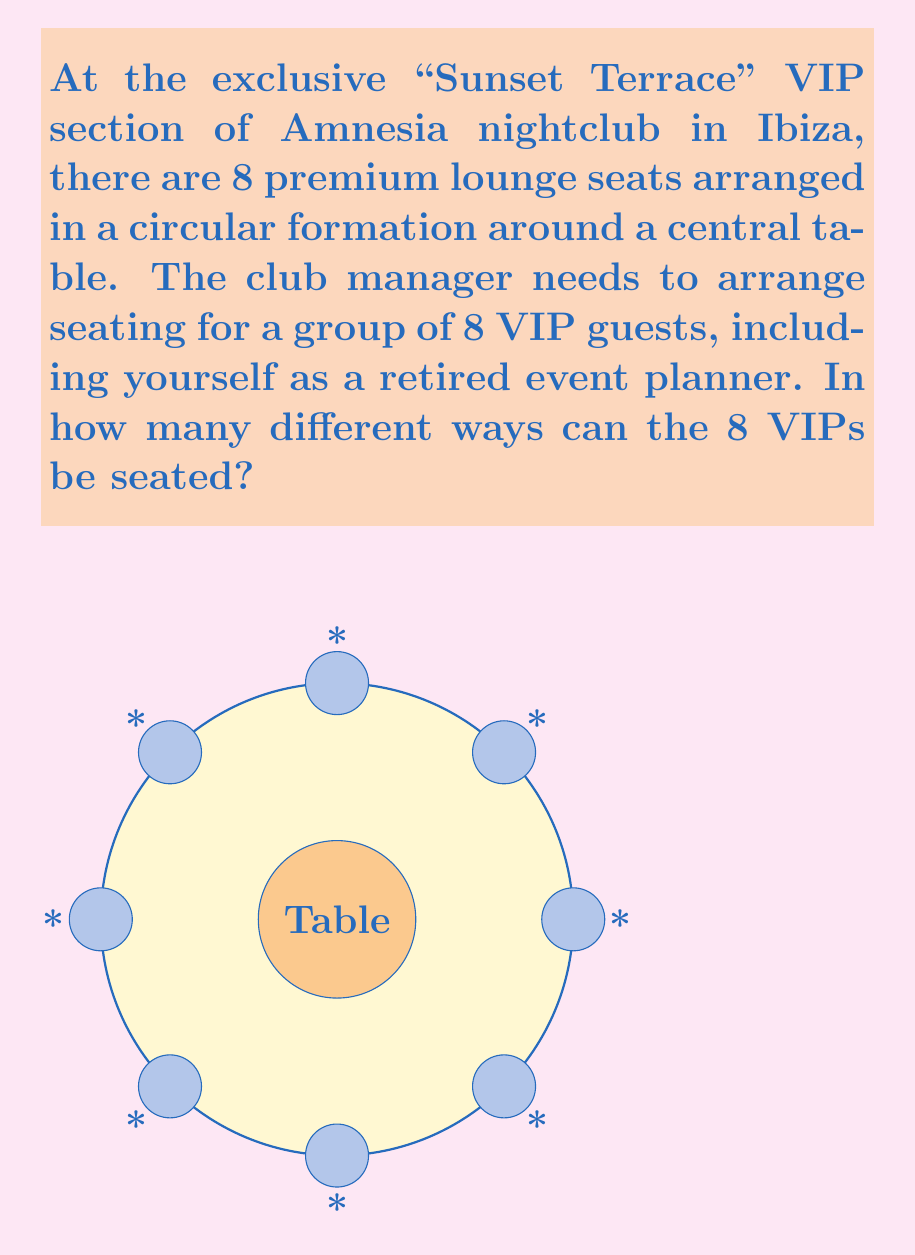Can you answer this question? Let's approach this step-by-step:

1) At first glance, this might seem like a straightforward permutation of 8 people, which would be 8! (8 factorial).

2) However, we need to consider that this is a circular arrangement. In a circular permutation, rotations of the same arrangement are considered identical.

3) For instance, if we have the arrangement ABCDEFGH, it's considered the same as BCDEFGHA, CDEFGHAB, and so on, as they're just rotations of the same arrangement.

4) In circular permutations, we fix one person's position and then arrange the rest. This effectively reduces the number of permutations by a factor of n (where n is the total number of people).

5) Therefore, the formula for circular permutations is:

   $$(n-1)!$$

   Where n is the total number of people.

6) In this case, n = 8, so we calculate:

   $$(8-1)! = 7! = 7 \times 6 \times 5 \times 4 \times 3 \times 2 \times 1 = 5040$$

Therefore, there are 5040 different ways to arrange the 8 VIPs in the circular seating arrangement.
Answer: 5040 